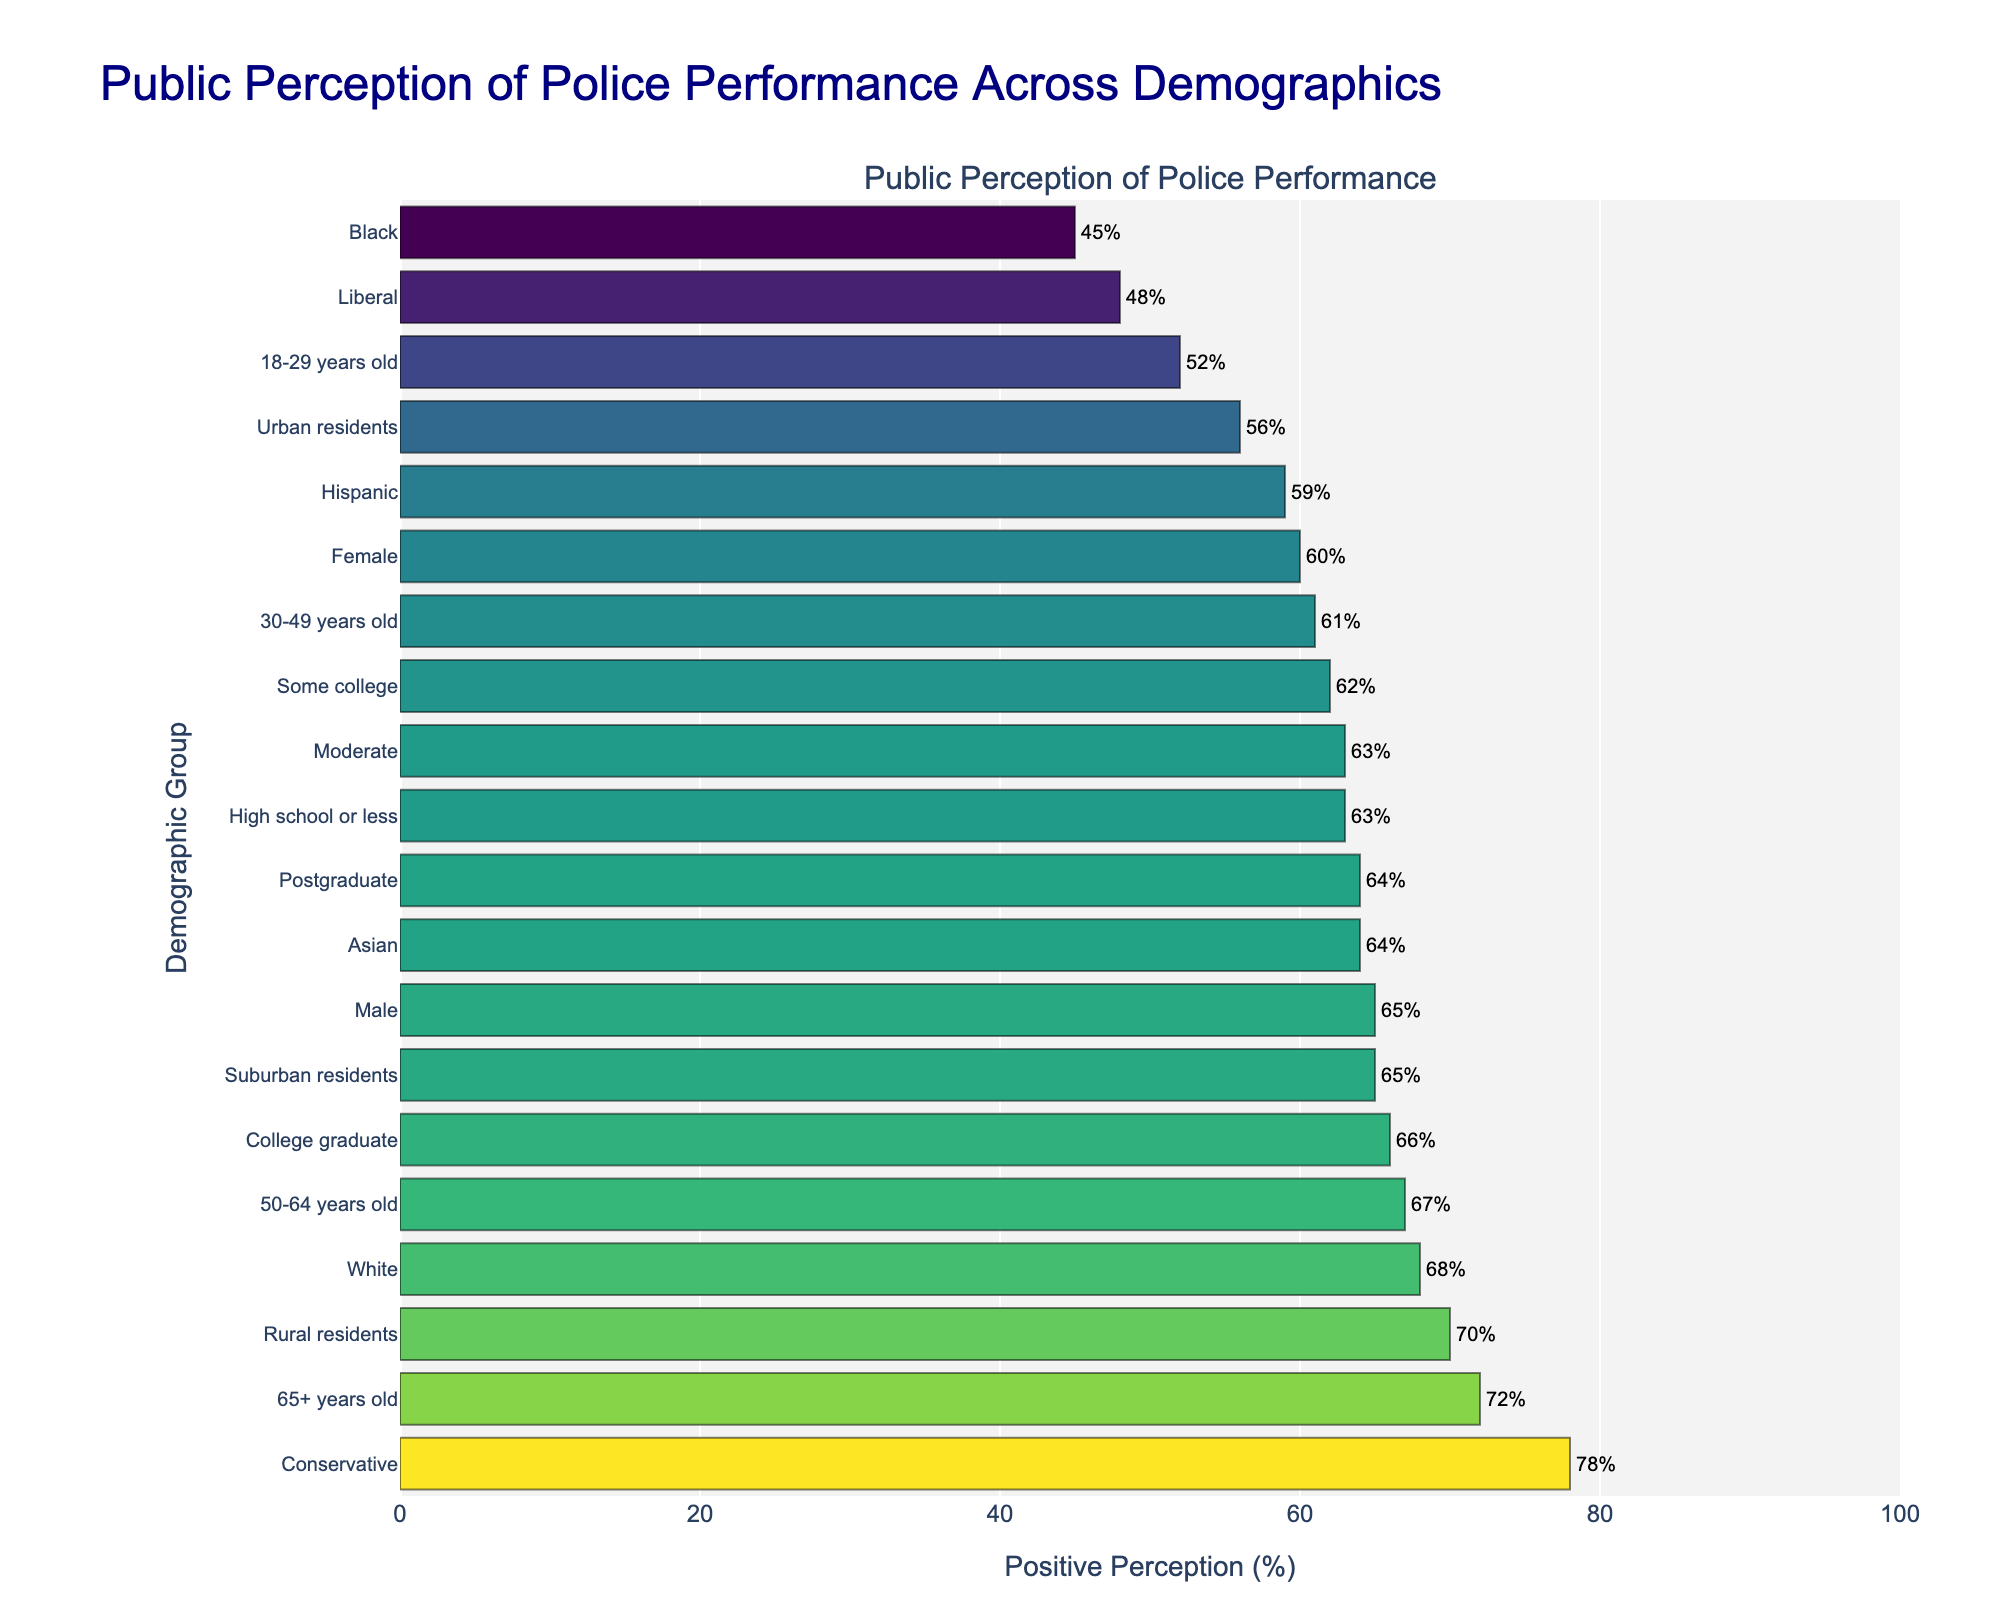Which demographic group has the highest positive perception of police performance? To find the group with the highest positive perception, locate the bar representing the highest value. The "Conservative" group has the highest positive perception of police performance at 78%.
Answer: Conservative Which two age groups have the closest positive perception percentages? Compare the values for each age group. The "30-49 years old" group has 61%, and the "Some college" group has 62%.
Answer: 30-49 years old and Some college What is the average positive perception of police performance across all demographic groups? Add all the percentages together and then divide by the number of demographic groups (21). (68+45+59+64+52+61+67+72+56+65+70+63+62+66+64+48+63+78+65+60)=1208, then 1208/21=57.52%.
Answer: 57.52% What is the difference in positive perception between "Urban residents" and "Rural residents"? Subtract the percentage for "Urban residents" (56%) from "Rural residents" (70%). 70 - 56 = 14.
Answer: 14% Is the positive perception of police performance among "Male" higher or lower than that among "Female"? Compare the percentages for "Male" (65%) and "Female" (60%). Since 65 is greater than 60, "Male" has a higher positive perception than "Female".
Answer: Higher How does the perception of police performance among "Liberals" compare to that among "Conservatives"? Compare the bar lengths for "Liberals" (48%) and "Conservatives" (78%). "Conservatives" have a higher positive perception than "Liberals".
Answer: Conservatives have a higher perception What is the range of positive perception percentages across the demographic groups? Identify the maximum and minimum values. The maximum is 78% (Conservatives), and the minimum is 45% (Black). Calculate the range: 78 - 45 = 33.
Answer: 33% How many demographic groups have a positive perception of police performance greater than 60%? Count the number of bars with values greater than 60%. The groups are White, Asian, 50-64 years old, 65+ years old, Suburban residents, Rural residents, College graduate, Conservative, and Male, totaling 9 groups.
Answer: 9 Which demographic group has the lowest positive perception of police performance? Find the shortest bar, which represents the lowest value. The "Black" demographic group has the lowest positive perception at 45%.
Answer: Black 